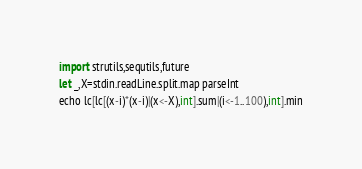<code> <loc_0><loc_0><loc_500><loc_500><_Nim_>import strutils,sequtils,future
let _,X=stdin.readLine.split.map parseInt
echo lc[lc[(x-i)*(x-i)|(x<-X),int].sum|(i<-1..100),int].min</code> 